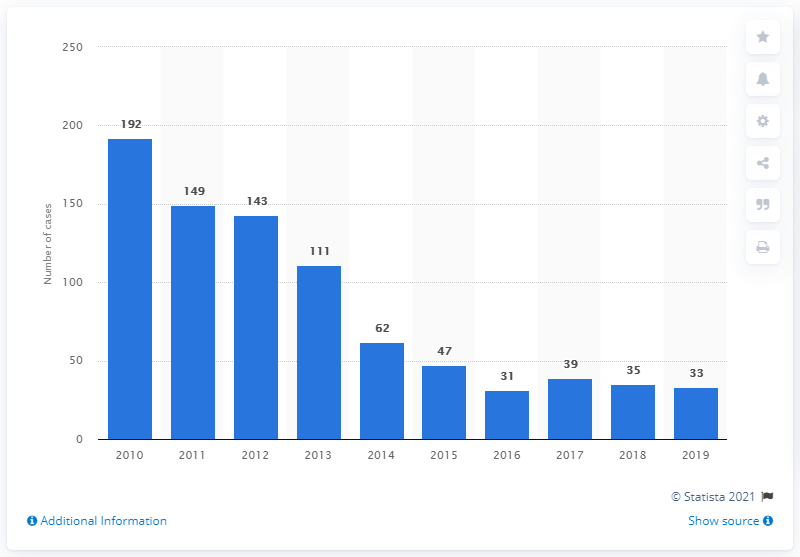How many malaria cases were reported in Singapore in 2019? In 2019, Singapore reported 33 malaria cases, as seen in the bar graph. This continues the downward trend observed over the previous decade, reflecting effective public health strategies and interventions. 